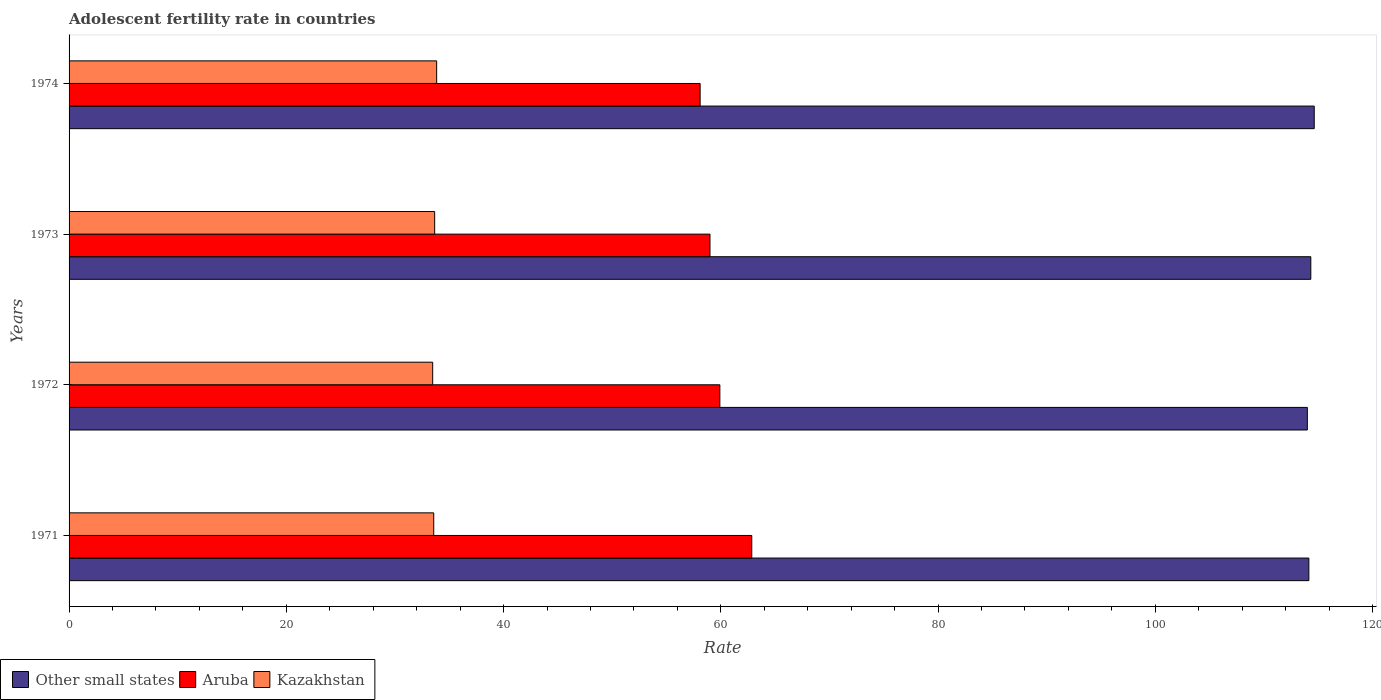How many groups of bars are there?
Your answer should be compact. 4. What is the label of the 1st group of bars from the top?
Keep it short and to the point. 1974. In how many cases, is the number of bars for a given year not equal to the number of legend labels?
Provide a short and direct response. 0. What is the adolescent fertility rate in Other small states in 1974?
Provide a short and direct response. 114.63. Across all years, what is the maximum adolescent fertility rate in Kazakhstan?
Provide a succinct answer. 33.84. Across all years, what is the minimum adolescent fertility rate in Other small states?
Your answer should be very brief. 114. In which year was the adolescent fertility rate in Aruba minimum?
Keep it short and to the point. 1974. What is the total adolescent fertility rate in Aruba in the graph?
Your answer should be very brief. 239.86. What is the difference between the adolescent fertility rate in Other small states in 1971 and that in 1972?
Make the answer very short. 0.14. What is the difference between the adolescent fertility rate in Other small states in 1973 and the adolescent fertility rate in Aruba in 1972?
Make the answer very short. 54.4. What is the average adolescent fertility rate in Aruba per year?
Offer a terse response. 59.97. In the year 1974, what is the difference between the adolescent fertility rate in Kazakhstan and adolescent fertility rate in Other small states?
Give a very brief answer. -80.79. In how many years, is the adolescent fertility rate in Other small states greater than 116 ?
Offer a very short reply. 0. What is the ratio of the adolescent fertility rate in Kazakhstan in 1971 to that in 1974?
Ensure brevity in your answer.  0.99. Is the adolescent fertility rate in Other small states in 1971 less than that in 1974?
Keep it short and to the point. Yes. Is the difference between the adolescent fertility rate in Kazakhstan in 1973 and 1974 greater than the difference between the adolescent fertility rate in Other small states in 1973 and 1974?
Your answer should be compact. Yes. What is the difference between the highest and the second highest adolescent fertility rate in Aruba?
Your answer should be compact. 2.94. What is the difference between the highest and the lowest adolescent fertility rate in Kazakhstan?
Provide a succinct answer. 0.37. In how many years, is the adolescent fertility rate in Other small states greater than the average adolescent fertility rate in Other small states taken over all years?
Your response must be concise. 2. Is the sum of the adolescent fertility rate in Kazakhstan in 1971 and 1972 greater than the maximum adolescent fertility rate in Aruba across all years?
Offer a very short reply. Yes. What does the 1st bar from the top in 1972 represents?
Offer a very short reply. Kazakhstan. What does the 3rd bar from the bottom in 1972 represents?
Keep it short and to the point. Kazakhstan. Is it the case that in every year, the sum of the adolescent fertility rate in Aruba and adolescent fertility rate in Kazakhstan is greater than the adolescent fertility rate in Other small states?
Provide a short and direct response. No. How many bars are there?
Your response must be concise. 12. Are all the bars in the graph horizontal?
Give a very brief answer. Yes. Does the graph contain grids?
Ensure brevity in your answer.  No. Where does the legend appear in the graph?
Keep it short and to the point. Bottom left. What is the title of the graph?
Your response must be concise. Adolescent fertility rate in countries. Does "Uzbekistan" appear as one of the legend labels in the graph?
Your answer should be compact. No. What is the label or title of the X-axis?
Provide a succinct answer. Rate. What is the Rate in Other small states in 1971?
Offer a very short reply. 114.14. What is the Rate of Aruba in 1971?
Your answer should be compact. 62.85. What is the Rate of Kazakhstan in 1971?
Your answer should be compact. 33.57. What is the Rate in Other small states in 1972?
Offer a very short reply. 114. What is the Rate of Aruba in 1972?
Ensure brevity in your answer.  59.91. What is the Rate in Kazakhstan in 1972?
Keep it short and to the point. 33.48. What is the Rate of Other small states in 1973?
Ensure brevity in your answer.  114.32. What is the Rate of Aruba in 1973?
Make the answer very short. 59. What is the Rate in Kazakhstan in 1973?
Ensure brevity in your answer.  33.66. What is the Rate in Other small states in 1974?
Your response must be concise. 114.63. What is the Rate of Aruba in 1974?
Make the answer very short. 58.1. What is the Rate in Kazakhstan in 1974?
Your answer should be compact. 33.84. Across all years, what is the maximum Rate in Other small states?
Give a very brief answer. 114.63. Across all years, what is the maximum Rate of Aruba?
Make the answer very short. 62.85. Across all years, what is the maximum Rate in Kazakhstan?
Ensure brevity in your answer.  33.84. Across all years, what is the minimum Rate of Other small states?
Keep it short and to the point. 114. Across all years, what is the minimum Rate in Aruba?
Provide a succinct answer. 58.1. Across all years, what is the minimum Rate of Kazakhstan?
Your answer should be compact. 33.48. What is the total Rate of Other small states in the graph?
Your answer should be compact. 457.08. What is the total Rate in Aruba in the graph?
Keep it short and to the point. 239.86. What is the total Rate in Kazakhstan in the graph?
Offer a terse response. 134.55. What is the difference between the Rate of Other small states in 1971 and that in 1972?
Give a very brief answer. 0.14. What is the difference between the Rate in Aruba in 1971 and that in 1972?
Provide a succinct answer. 2.94. What is the difference between the Rate in Kazakhstan in 1971 and that in 1972?
Make the answer very short. 0.1. What is the difference between the Rate in Other small states in 1971 and that in 1973?
Your response must be concise. -0.18. What is the difference between the Rate of Aruba in 1971 and that in 1973?
Your answer should be compact. 3.85. What is the difference between the Rate of Kazakhstan in 1971 and that in 1973?
Your response must be concise. -0.09. What is the difference between the Rate in Other small states in 1971 and that in 1974?
Give a very brief answer. -0.5. What is the difference between the Rate of Aruba in 1971 and that in 1974?
Give a very brief answer. 4.76. What is the difference between the Rate in Kazakhstan in 1971 and that in 1974?
Provide a short and direct response. -0.27. What is the difference between the Rate of Other small states in 1972 and that in 1973?
Your answer should be very brief. -0.32. What is the difference between the Rate in Aruba in 1972 and that in 1973?
Provide a short and direct response. 0.91. What is the difference between the Rate of Kazakhstan in 1972 and that in 1973?
Give a very brief answer. -0.18. What is the difference between the Rate in Other small states in 1972 and that in 1974?
Your answer should be compact. -0.63. What is the difference between the Rate in Aruba in 1972 and that in 1974?
Offer a terse response. 1.82. What is the difference between the Rate of Kazakhstan in 1972 and that in 1974?
Give a very brief answer. -0.37. What is the difference between the Rate of Other small states in 1973 and that in 1974?
Provide a short and direct response. -0.31. What is the difference between the Rate of Aruba in 1973 and that in 1974?
Offer a terse response. 0.91. What is the difference between the Rate in Kazakhstan in 1973 and that in 1974?
Make the answer very short. -0.18. What is the difference between the Rate of Other small states in 1971 and the Rate of Aruba in 1972?
Ensure brevity in your answer.  54.22. What is the difference between the Rate in Other small states in 1971 and the Rate in Kazakhstan in 1972?
Make the answer very short. 80.66. What is the difference between the Rate of Aruba in 1971 and the Rate of Kazakhstan in 1972?
Provide a succinct answer. 29.38. What is the difference between the Rate of Other small states in 1971 and the Rate of Aruba in 1973?
Ensure brevity in your answer.  55.13. What is the difference between the Rate in Other small states in 1971 and the Rate in Kazakhstan in 1973?
Make the answer very short. 80.48. What is the difference between the Rate of Aruba in 1971 and the Rate of Kazakhstan in 1973?
Make the answer very short. 29.19. What is the difference between the Rate in Other small states in 1971 and the Rate in Aruba in 1974?
Ensure brevity in your answer.  56.04. What is the difference between the Rate of Other small states in 1971 and the Rate of Kazakhstan in 1974?
Ensure brevity in your answer.  80.3. What is the difference between the Rate in Aruba in 1971 and the Rate in Kazakhstan in 1974?
Make the answer very short. 29.01. What is the difference between the Rate in Other small states in 1972 and the Rate in Aruba in 1973?
Provide a succinct answer. 54.99. What is the difference between the Rate of Other small states in 1972 and the Rate of Kazakhstan in 1973?
Offer a very short reply. 80.34. What is the difference between the Rate of Aruba in 1972 and the Rate of Kazakhstan in 1973?
Provide a succinct answer. 26.25. What is the difference between the Rate in Other small states in 1972 and the Rate in Aruba in 1974?
Offer a very short reply. 55.9. What is the difference between the Rate in Other small states in 1972 and the Rate in Kazakhstan in 1974?
Keep it short and to the point. 80.16. What is the difference between the Rate in Aruba in 1972 and the Rate in Kazakhstan in 1974?
Make the answer very short. 26.07. What is the difference between the Rate in Other small states in 1973 and the Rate in Aruba in 1974?
Your answer should be compact. 56.22. What is the difference between the Rate in Other small states in 1973 and the Rate in Kazakhstan in 1974?
Your answer should be compact. 80.48. What is the difference between the Rate in Aruba in 1973 and the Rate in Kazakhstan in 1974?
Ensure brevity in your answer.  25.16. What is the average Rate in Other small states per year?
Keep it short and to the point. 114.27. What is the average Rate of Aruba per year?
Your response must be concise. 59.97. What is the average Rate in Kazakhstan per year?
Provide a short and direct response. 33.64. In the year 1971, what is the difference between the Rate in Other small states and Rate in Aruba?
Make the answer very short. 51.29. In the year 1971, what is the difference between the Rate of Other small states and Rate of Kazakhstan?
Ensure brevity in your answer.  80.56. In the year 1971, what is the difference between the Rate in Aruba and Rate in Kazakhstan?
Offer a terse response. 29.28. In the year 1972, what is the difference between the Rate in Other small states and Rate in Aruba?
Make the answer very short. 54.08. In the year 1972, what is the difference between the Rate of Other small states and Rate of Kazakhstan?
Give a very brief answer. 80.52. In the year 1972, what is the difference between the Rate of Aruba and Rate of Kazakhstan?
Provide a succinct answer. 26.44. In the year 1973, what is the difference between the Rate in Other small states and Rate in Aruba?
Your response must be concise. 55.31. In the year 1973, what is the difference between the Rate of Other small states and Rate of Kazakhstan?
Give a very brief answer. 80.66. In the year 1973, what is the difference between the Rate of Aruba and Rate of Kazakhstan?
Your answer should be compact. 25.35. In the year 1974, what is the difference between the Rate in Other small states and Rate in Aruba?
Keep it short and to the point. 56.54. In the year 1974, what is the difference between the Rate of Other small states and Rate of Kazakhstan?
Offer a terse response. 80.79. In the year 1974, what is the difference between the Rate of Aruba and Rate of Kazakhstan?
Give a very brief answer. 24.25. What is the ratio of the Rate in Other small states in 1971 to that in 1972?
Your answer should be compact. 1. What is the ratio of the Rate in Aruba in 1971 to that in 1972?
Your response must be concise. 1.05. What is the ratio of the Rate in Kazakhstan in 1971 to that in 1972?
Provide a short and direct response. 1. What is the ratio of the Rate in Aruba in 1971 to that in 1973?
Give a very brief answer. 1.07. What is the ratio of the Rate of Kazakhstan in 1971 to that in 1973?
Your response must be concise. 1. What is the ratio of the Rate of Aruba in 1971 to that in 1974?
Offer a very short reply. 1.08. What is the ratio of the Rate in Other small states in 1972 to that in 1973?
Provide a succinct answer. 1. What is the ratio of the Rate in Aruba in 1972 to that in 1973?
Your answer should be compact. 1.02. What is the ratio of the Rate of Kazakhstan in 1972 to that in 1973?
Keep it short and to the point. 0.99. What is the ratio of the Rate of Aruba in 1972 to that in 1974?
Provide a succinct answer. 1.03. What is the ratio of the Rate in Kazakhstan in 1972 to that in 1974?
Provide a short and direct response. 0.99. What is the ratio of the Rate of Aruba in 1973 to that in 1974?
Give a very brief answer. 1.02. What is the ratio of the Rate in Kazakhstan in 1973 to that in 1974?
Offer a very short reply. 0.99. What is the difference between the highest and the second highest Rate in Other small states?
Keep it short and to the point. 0.31. What is the difference between the highest and the second highest Rate in Aruba?
Keep it short and to the point. 2.94. What is the difference between the highest and the second highest Rate of Kazakhstan?
Keep it short and to the point. 0.18. What is the difference between the highest and the lowest Rate in Other small states?
Ensure brevity in your answer.  0.63. What is the difference between the highest and the lowest Rate of Aruba?
Keep it short and to the point. 4.76. What is the difference between the highest and the lowest Rate in Kazakhstan?
Ensure brevity in your answer.  0.37. 